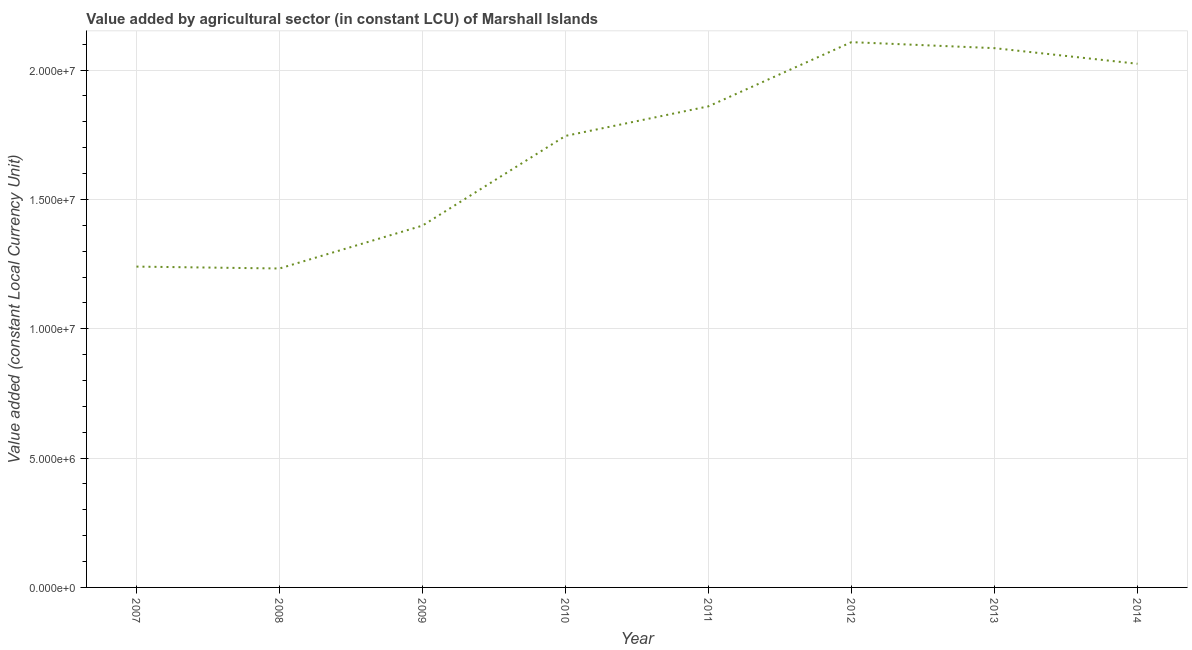What is the value added by agriculture sector in 2010?
Provide a succinct answer. 1.75e+07. Across all years, what is the maximum value added by agriculture sector?
Your response must be concise. 2.11e+07. Across all years, what is the minimum value added by agriculture sector?
Your answer should be very brief. 1.23e+07. What is the sum of the value added by agriculture sector?
Offer a very short reply. 1.37e+08. What is the difference between the value added by agriculture sector in 2008 and 2013?
Give a very brief answer. -8.52e+06. What is the average value added by agriculture sector per year?
Offer a very short reply. 1.71e+07. What is the median value added by agriculture sector?
Make the answer very short. 1.80e+07. Do a majority of the years between 2010 and 2012 (inclusive) have value added by agriculture sector greater than 14000000 LCU?
Provide a succinct answer. Yes. What is the ratio of the value added by agriculture sector in 2009 to that in 2011?
Ensure brevity in your answer.  0.75. What is the difference between the highest and the second highest value added by agriculture sector?
Offer a terse response. 2.32e+05. What is the difference between the highest and the lowest value added by agriculture sector?
Make the answer very short. 8.75e+06. In how many years, is the value added by agriculture sector greater than the average value added by agriculture sector taken over all years?
Provide a succinct answer. 5. Does the value added by agriculture sector monotonically increase over the years?
Your answer should be compact. No. How many years are there in the graph?
Make the answer very short. 8. What is the difference between two consecutive major ticks on the Y-axis?
Ensure brevity in your answer.  5.00e+06. Does the graph contain any zero values?
Make the answer very short. No. What is the title of the graph?
Your response must be concise. Value added by agricultural sector (in constant LCU) of Marshall Islands. What is the label or title of the X-axis?
Provide a succinct answer. Year. What is the label or title of the Y-axis?
Make the answer very short. Value added (constant Local Currency Unit). What is the Value added (constant Local Currency Unit) in 2007?
Provide a short and direct response. 1.24e+07. What is the Value added (constant Local Currency Unit) of 2008?
Keep it short and to the point. 1.23e+07. What is the Value added (constant Local Currency Unit) of 2009?
Offer a very short reply. 1.40e+07. What is the Value added (constant Local Currency Unit) of 2010?
Provide a succinct answer. 1.75e+07. What is the Value added (constant Local Currency Unit) in 2011?
Ensure brevity in your answer.  1.86e+07. What is the Value added (constant Local Currency Unit) in 2012?
Make the answer very short. 2.11e+07. What is the Value added (constant Local Currency Unit) of 2013?
Your answer should be compact. 2.08e+07. What is the Value added (constant Local Currency Unit) of 2014?
Your response must be concise. 2.02e+07. What is the difference between the Value added (constant Local Currency Unit) in 2007 and 2008?
Make the answer very short. 7.34e+04. What is the difference between the Value added (constant Local Currency Unit) in 2007 and 2009?
Your response must be concise. -1.58e+06. What is the difference between the Value added (constant Local Currency Unit) in 2007 and 2010?
Ensure brevity in your answer.  -5.05e+06. What is the difference between the Value added (constant Local Currency Unit) in 2007 and 2011?
Your response must be concise. -6.20e+06. What is the difference between the Value added (constant Local Currency Unit) in 2007 and 2012?
Give a very brief answer. -8.68e+06. What is the difference between the Value added (constant Local Currency Unit) in 2007 and 2013?
Offer a terse response. -8.44e+06. What is the difference between the Value added (constant Local Currency Unit) in 2007 and 2014?
Provide a short and direct response. -7.84e+06. What is the difference between the Value added (constant Local Currency Unit) in 2008 and 2009?
Offer a terse response. -1.66e+06. What is the difference between the Value added (constant Local Currency Unit) in 2008 and 2010?
Your answer should be very brief. -5.13e+06. What is the difference between the Value added (constant Local Currency Unit) in 2008 and 2011?
Your response must be concise. -6.27e+06. What is the difference between the Value added (constant Local Currency Unit) in 2008 and 2012?
Provide a succinct answer. -8.75e+06. What is the difference between the Value added (constant Local Currency Unit) in 2008 and 2013?
Give a very brief answer. -8.52e+06. What is the difference between the Value added (constant Local Currency Unit) in 2008 and 2014?
Provide a succinct answer. -7.91e+06. What is the difference between the Value added (constant Local Currency Unit) in 2009 and 2010?
Give a very brief answer. -3.47e+06. What is the difference between the Value added (constant Local Currency Unit) in 2009 and 2011?
Make the answer very short. -4.61e+06. What is the difference between the Value added (constant Local Currency Unit) in 2009 and 2012?
Ensure brevity in your answer.  -7.09e+06. What is the difference between the Value added (constant Local Currency Unit) in 2009 and 2013?
Your answer should be very brief. -6.86e+06. What is the difference between the Value added (constant Local Currency Unit) in 2009 and 2014?
Give a very brief answer. -6.26e+06. What is the difference between the Value added (constant Local Currency Unit) in 2010 and 2011?
Your answer should be very brief. -1.14e+06. What is the difference between the Value added (constant Local Currency Unit) in 2010 and 2012?
Ensure brevity in your answer.  -3.62e+06. What is the difference between the Value added (constant Local Currency Unit) in 2010 and 2013?
Provide a succinct answer. -3.39e+06. What is the difference between the Value added (constant Local Currency Unit) in 2010 and 2014?
Offer a terse response. -2.79e+06. What is the difference between the Value added (constant Local Currency Unit) in 2011 and 2012?
Give a very brief answer. -2.48e+06. What is the difference between the Value added (constant Local Currency Unit) in 2011 and 2013?
Your answer should be compact. -2.25e+06. What is the difference between the Value added (constant Local Currency Unit) in 2011 and 2014?
Ensure brevity in your answer.  -1.65e+06. What is the difference between the Value added (constant Local Currency Unit) in 2012 and 2013?
Your response must be concise. 2.32e+05. What is the difference between the Value added (constant Local Currency Unit) in 2012 and 2014?
Ensure brevity in your answer.  8.36e+05. What is the difference between the Value added (constant Local Currency Unit) in 2013 and 2014?
Your response must be concise. 6.03e+05. What is the ratio of the Value added (constant Local Currency Unit) in 2007 to that in 2009?
Make the answer very short. 0.89. What is the ratio of the Value added (constant Local Currency Unit) in 2007 to that in 2010?
Your response must be concise. 0.71. What is the ratio of the Value added (constant Local Currency Unit) in 2007 to that in 2011?
Ensure brevity in your answer.  0.67. What is the ratio of the Value added (constant Local Currency Unit) in 2007 to that in 2012?
Provide a succinct answer. 0.59. What is the ratio of the Value added (constant Local Currency Unit) in 2007 to that in 2013?
Your answer should be very brief. 0.59. What is the ratio of the Value added (constant Local Currency Unit) in 2007 to that in 2014?
Provide a short and direct response. 0.61. What is the ratio of the Value added (constant Local Currency Unit) in 2008 to that in 2009?
Give a very brief answer. 0.88. What is the ratio of the Value added (constant Local Currency Unit) in 2008 to that in 2010?
Offer a terse response. 0.71. What is the ratio of the Value added (constant Local Currency Unit) in 2008 to that in 2011?
Ensure brevity in your answer.  0.66. What is the ratio of the Value added (constant Local Currency Unit) in 2008 to that in 2012?
Give a very brief answer. 0.58. What is the ratio of the Value added (constant Local Currency Unit) in 2008 to that in 2013?
Offer a very short reply. 0.59. What is the ratio of the Value added (constant Local Currency Unit) in 2008 to that in 2014?
Your answer should be very brief. 0.61. What is the ratio of the Value added (constant Local Currency Unit) in 2009 to that in 2010?
Provide a succinct answer. 0.8. What is the ratio of the Value added (constant Local Currency Unit) in 2009 to that in 2011?
Offer a terse response. 0.75. What is the ratio of the Value added (constant Local Currency Unit) in 2009 to that in 2012?
Your answer should be very brief. 0.66. What is the ratio of the Value added (constant Local Currency Unit) in 2009 to that in 2013?
Your answer should be compact. 0.67. What is the ratio of the Value added (constant Local Currency Unit) in 2009 to that in 2014?
Your answer should be compact. 0.69. What is the ratio of the Value added (constant Local Currency Unit) in 2010 to that in 2011?
Provide a short and direct response. 0.94. What is the ratio of the Value added (constant Local Currency Unit) in 2010 to that in 2012?
Keep it short and to the point. 0.83. What is the ratio of the Value added (constant Local Currency Unit) in 2010 to that in 2013?
Make the answer very short. 0.84. What is the ratio of the Value added (constant Local Currency Unit) in 2010 to that in 2014?
Your answer should be compact. 0.86. What is the ratio of the Value added (constant Local Currency Unit) in 2011 to that in 2012?
Give a very brief answer. 0.88. What is the ratio of the Value added (constant Local Currency Unit) in 2011 to that in 2013?
Your response must be concise. 0.89. What is the ratio of the Value added (constant Local Currency Unit) in 2011 to that in 2014?
Provide a succinct answer. 0.92. What is the ratio of the Value added (constant Local Currency Unit) in 2012 to that in 2014?
Give a very brief answer. 1.04. What is the ratio of the Value added (constant Local Currency Unit) in 2013 to that in 2014?
Your response must be concise. 1.03. 